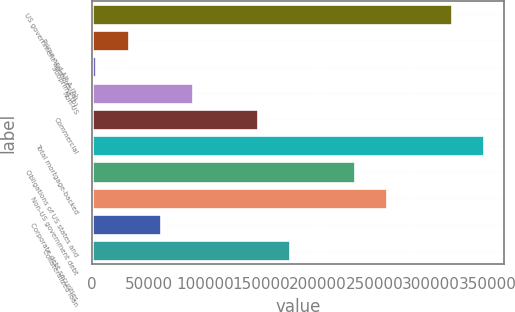<chart> <loc_0><loc_0><loc_500><loc_500><bar_chart><fcel>US government agencies (a)<fcel>Prime and Alt-A (b)<fcel>Subprime (b)<fcel>Non-US<fcel>Commercial<fcel>Total mortgage-backed<fcel>Obligations of US states and<fcel>Non-US government debt<fcel>Corporate debt securities<fcel>Collateralized loan<nl><fcel>318361<fcel>32551.9<fcel>3971<fcel>89713.7<fcel>146876<fcel>346942<fcel>232618<fcel>261199<fcel>61132.8<fcel>175456<nl></chart> 